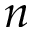<formula> <loc_0><loc_0><loc_500><loc_500>n</formula> 